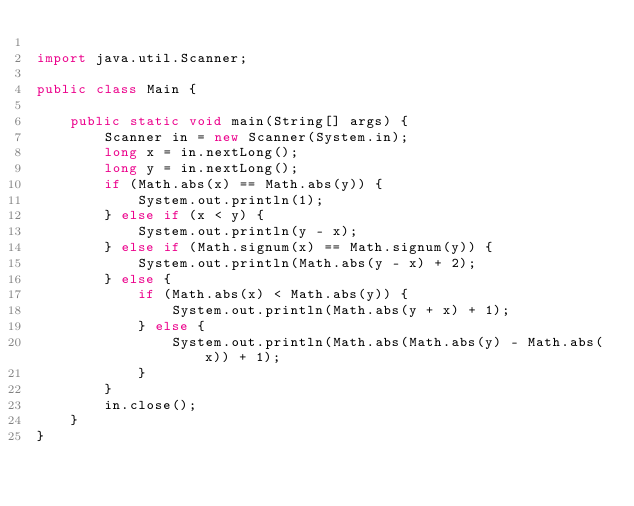Convert code to text. <code><loc_0><loc_0><loc_500><loc_500><_Java_>
import java.util.Scanner;

public class Main {

	public static void main(String[] args) {
		Scanner in = new Scanner(System.in);
		long x = in.nextLong();
		long y = in.nextLong();
		if (Math.abs(x) == Math.abs(y)) {
			System.out.println(1);
		} else if (x < y) {
			System.out.println(y - x);
		} else if (Math.signum(x) == Math.signum(y)) {
			System.out.println(Math.abs(y - x) + 2);
		} else {
			if (Math.abs(x) < Math.abs(y)) {
				System.out.println(Math.abs(y + x) + 1);
			} else {
				System.out.println(Math.abs(Math.abs(y) - Math.abs(x)) + 1);
			}
		}
		in.close();
	}
}</code> 